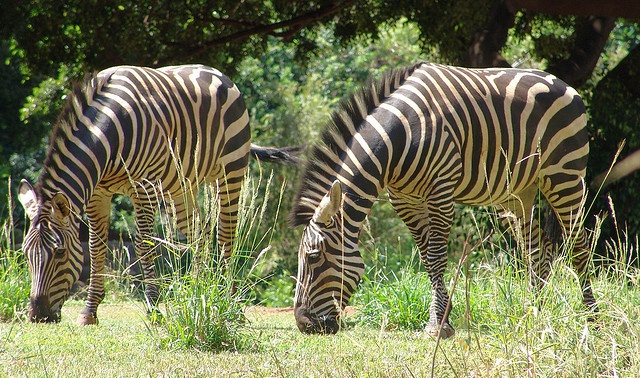Describe the objects in this image and their specific colors. I can see zebra in black, tan, gray, and olive tones and zebra in black, tan, olive, and gray tones in this image. 